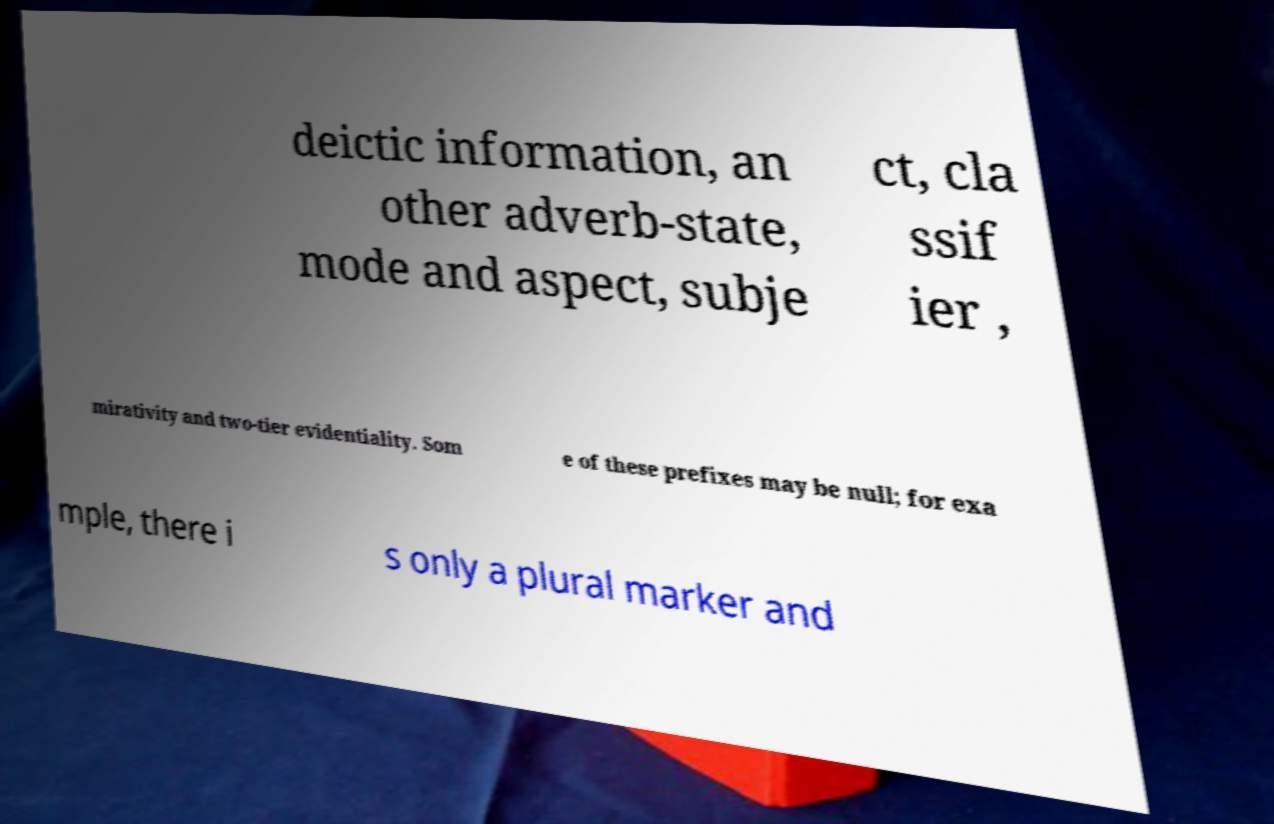For documentation purposes, I need the text within this image transcribed. Could you provide that? deictic information, an other adverb-state, mode and aspect, subje ct, cla ssif ier , mirativity and two-tier evidentiality. Som e of these prefixes may be null; for exa mple, there i s only a plural marker and 